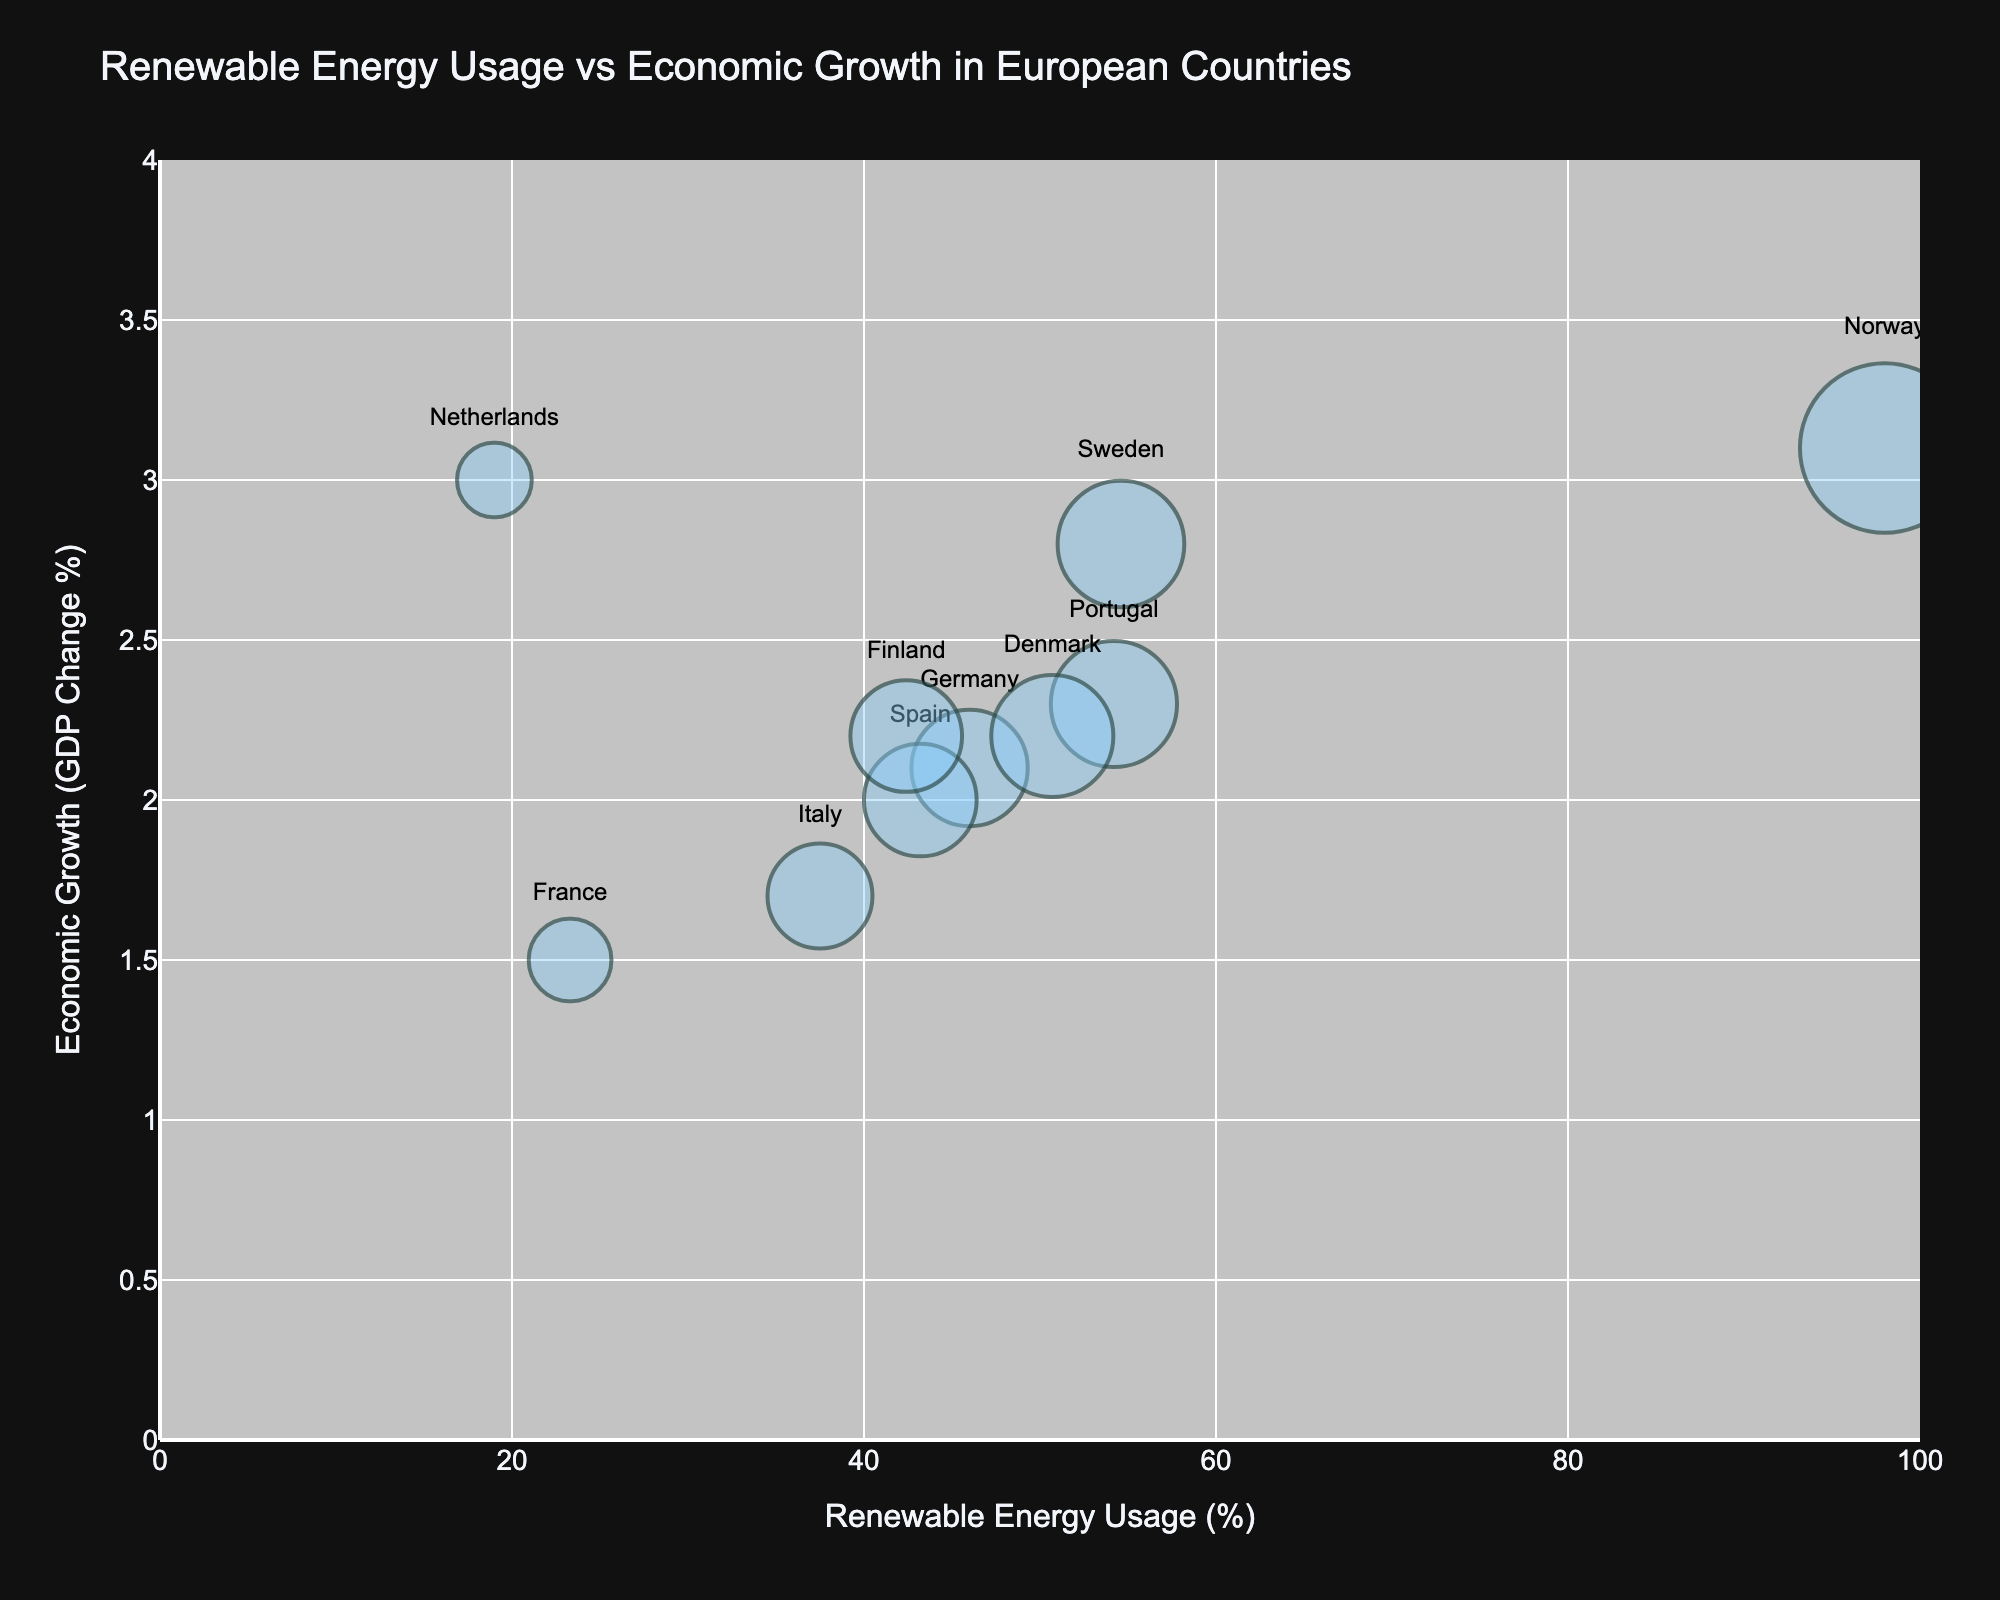What is the title of the chart? The title of a chart is typically located at the top and summarizes what the chart is about. The figure has a title that reads 'Renewable Energy Usage vs Economic Growth in European Countries'.
Answer: Renewable Energy Usage vs Economic Growth in European Countries Which country has the highest percentage of renewable energy usage? Review the figure to identify the bubble corresponding to the highest percentage on the x-axis. Norway's bubble is at the highest position on the x-axis, indicating it has the highest renewable energy usage.
Answer: Norway How many countries have a renewable energy usage percentage greater than 50%? Count the number of bubbles beyond the 50% mark on the x-axis. Norway, Sweden, Portugal, and Denmark are the countries with renewable energy usage greater than 50%.
Answer: 4 Which country has the lowest economic growth? Identify the bubble positioned lowest on the y-axis. France, with the lowest bubble position indicating an economic growth of 1.5%, has the lowest economic growth.
Answer: France What is the renewable energy usage percentage and economic growth of Finland? Locate Finland on the figure, and read the values on the x and y axes. Finland is positioned at 42.4% renewable energy usage and an economic growth of 2.2%.
Answer: 42.4%, 2.2% What is the average economic growth of the countries with more than 40% renewable energy usage? Identify countries with renewable energy usage over 40%, then calculate the average of their economic growth percentages. These countries are Norway (3.1), Sweden (2.8), Portugal (2.3), Denmark (2.2), Spain (2.0), and Finland (2.2). The average is (3.1 + 2.8 + 2.3 + 2.2 + 2.2 + 2.0) / 6.
Answer: 2.43% Which country has a higher economic growth, Germany or Italy? Compare the y-axis positions for Germany and Italy. Germany's bubble is positioned at 2.1% economic growth, and Italy's bubble is positioned at 1.7%.
Answer: Germany What appears larger visually, the bubble for Norway or the bubble for France? Compare the sizes of Norway's and France's bubbles in the chart. The bubble for Norway is larger, indicating a higher renewable energy usage compared to France.
Answer: Norway What is the difference in renewable energy usage percentage between Spain and the Netherlands? Find the bubbles for Spain and the Netherlands, then calculate the difference in their positions on the x-axis. Spain is at 43.2%, and the Netherlands is at 19%, so the difference is 43.2% - 19%.
Answer: 24.2% How does the economic growth correlate with renewable energy usage in general? Look at the overall trend in the positions of the bubbles. Many bubbles tend to have varying economic growth rates regardless of renewable energy usage, showing no clear linear correlation.
Answer: No clear correlation 